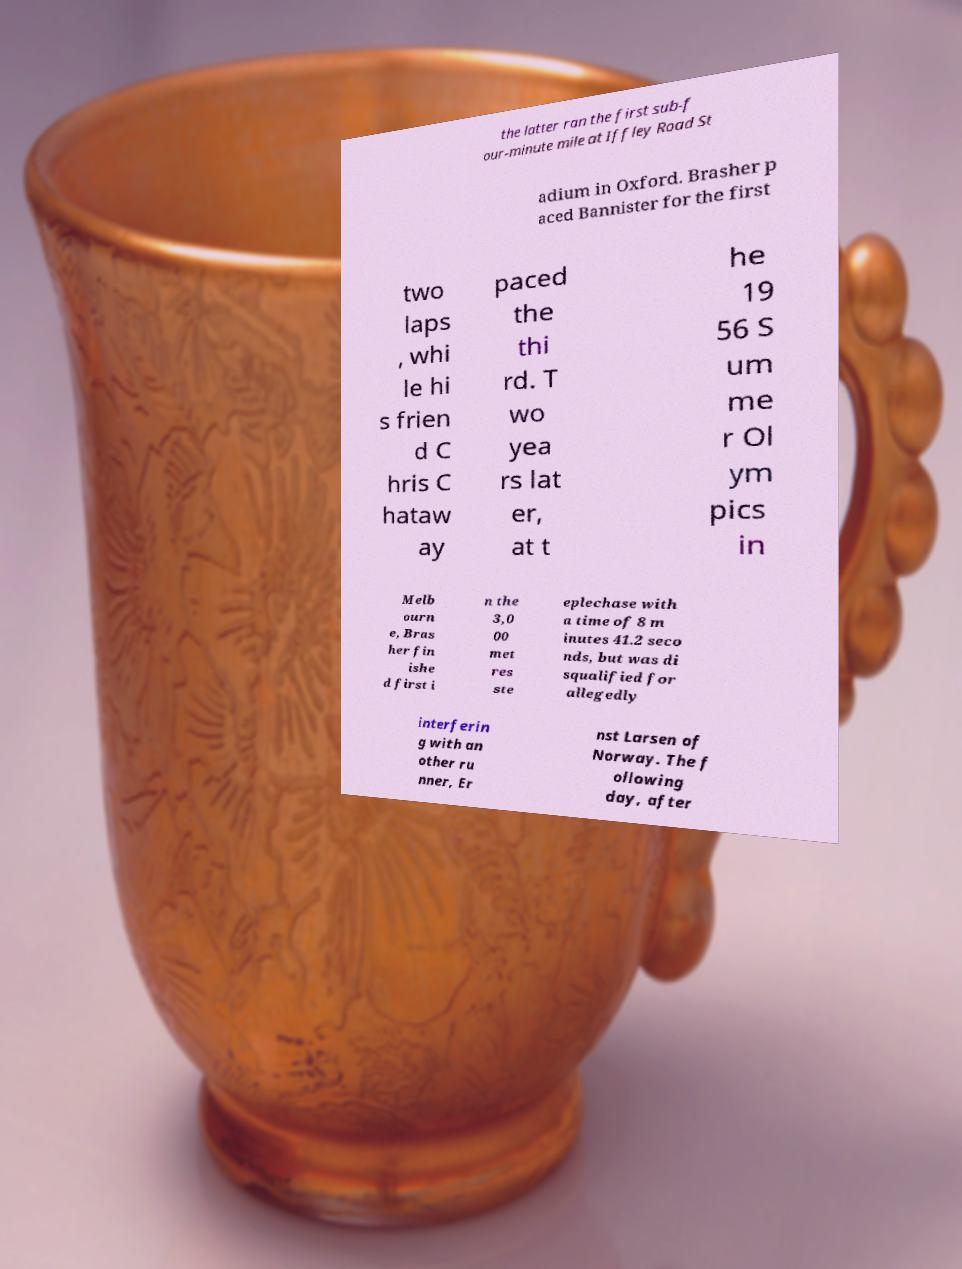There's text embedded in this image that I need extracted. Can you transcribe it verbatim? the latter ran the first sub-f our-minute mile at Iffley Road St adium in Oxford. Brasher p aced Bannister for the first two laps , whi le hi s frien d C hris C hataw ay paced the thi rd. T wo yea rs lat er, at t he 19 56 S um me r Ol ym pics in Melb ourn e, Bras her fin ishe d first i n the 3,0 00 met res ste eplechase with a time of 8 m inutes 41.2 seco nds, but was di squalified for allegedly interferin g with an other ru nner, Er nst Larsen of Norway. The f ollowing day, after 